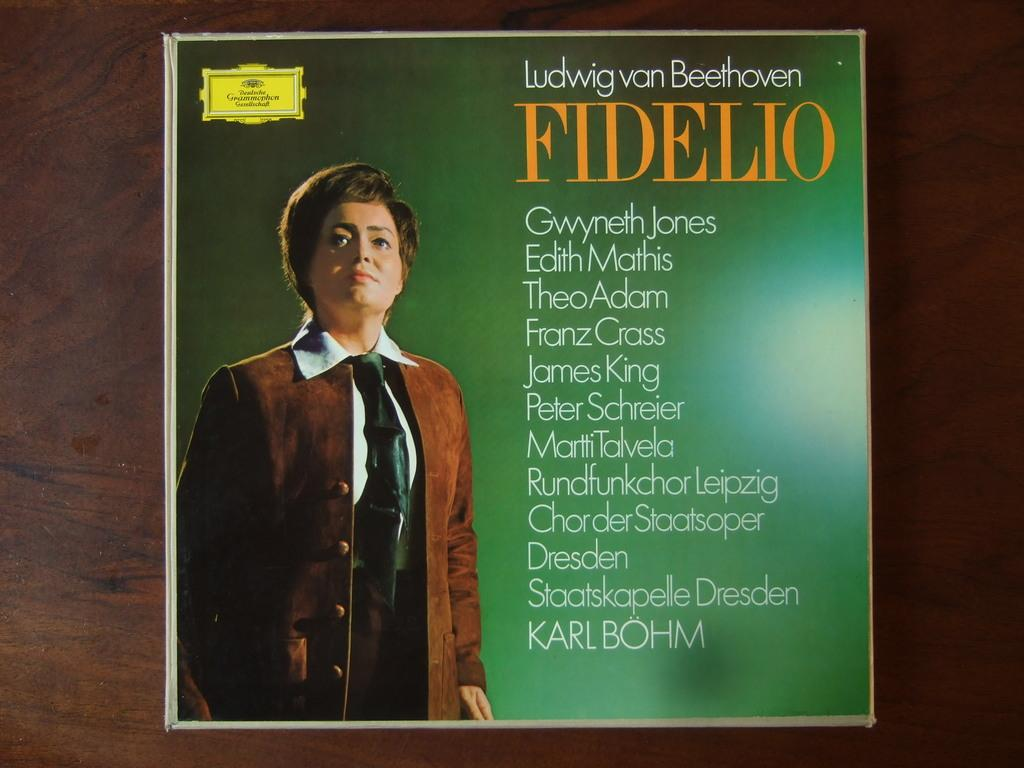<image>
Provide a brief description of the given image. A vinyl record for Ludwig Van Beethoven's Fidelio. 